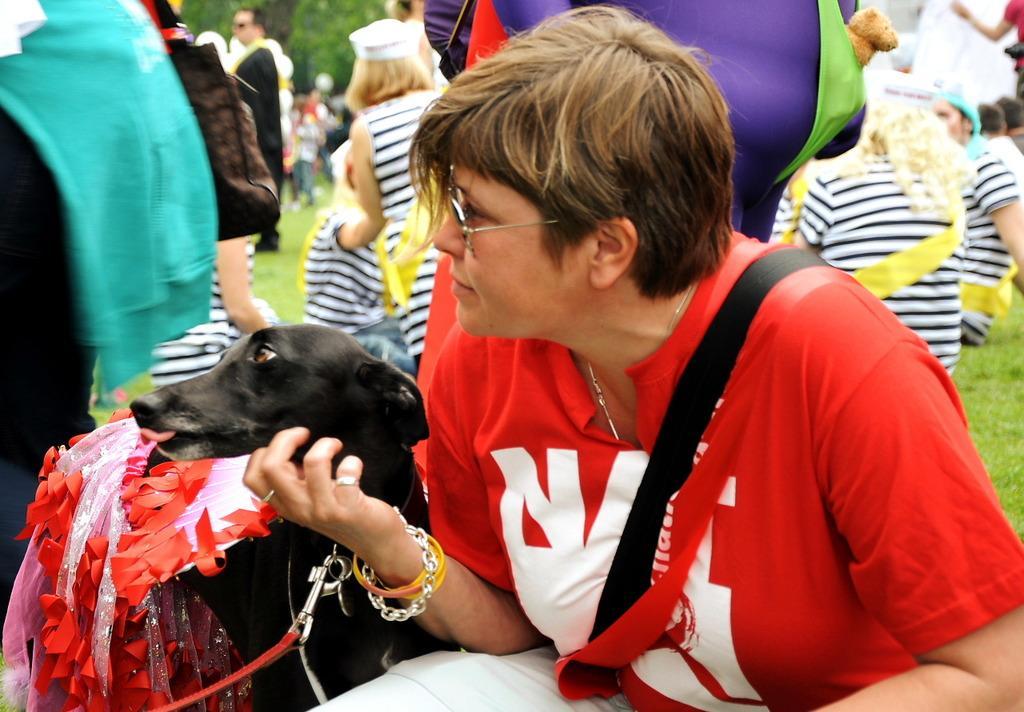Please provide a concise description of this image. In this image there are group of people. In front there is a woman wearing a bag and there is a dog in the garden. 